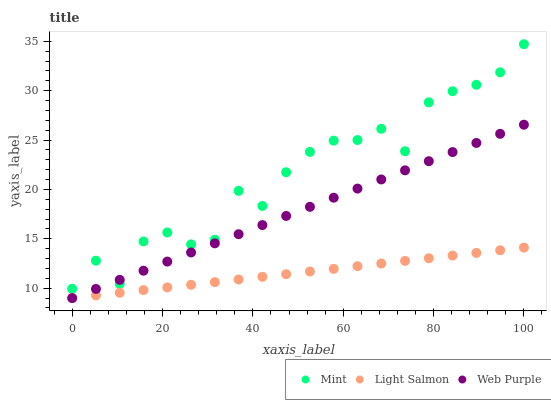Does Light Salmon have the minimum area under the curve?
Answer yes or no. Yes. Does Mint have the maximum area under the curve?
Answer yes or no. Yes. Does Web Purple have the minimum area under the curve?
Answer yes or no. No. Does Web Purple have the maximum area under the curve?
Answer yes or no. No. Is Light Salmon the smoothest?
Answer yes or no. Yes. Is Mint the roughest?
Answer yes or no. Yes. Is Web Purple the smoothest?
Answer yes or no. No. Is Web Purple the roughest?
Answer yes or no. No. Does Light Salmon have the lowest value?
Answer yes or no. Yes. Does Mint have the lowest value?
Answer yes or no. No. Does Mint have the highest value?
Answer yes or no. Yes. Does Web Purple have the highest value?
Answer yes or no. No. Is Light Salmon less than Mint?
Answer yes or no. Yes. Is Mint greater than Light Salmon?
Answer yes or no. Yes. Does Web Purple intersect Light Salmon?
Answer yes or no. Yes. Is Web Purple less than Light Salmon?
Answer yes or no. No. Is Web Purple greater than Light Salmon?
Answer yes or no. No. Does Light Salmon intersect Mint?
Answer yes or no. No. 